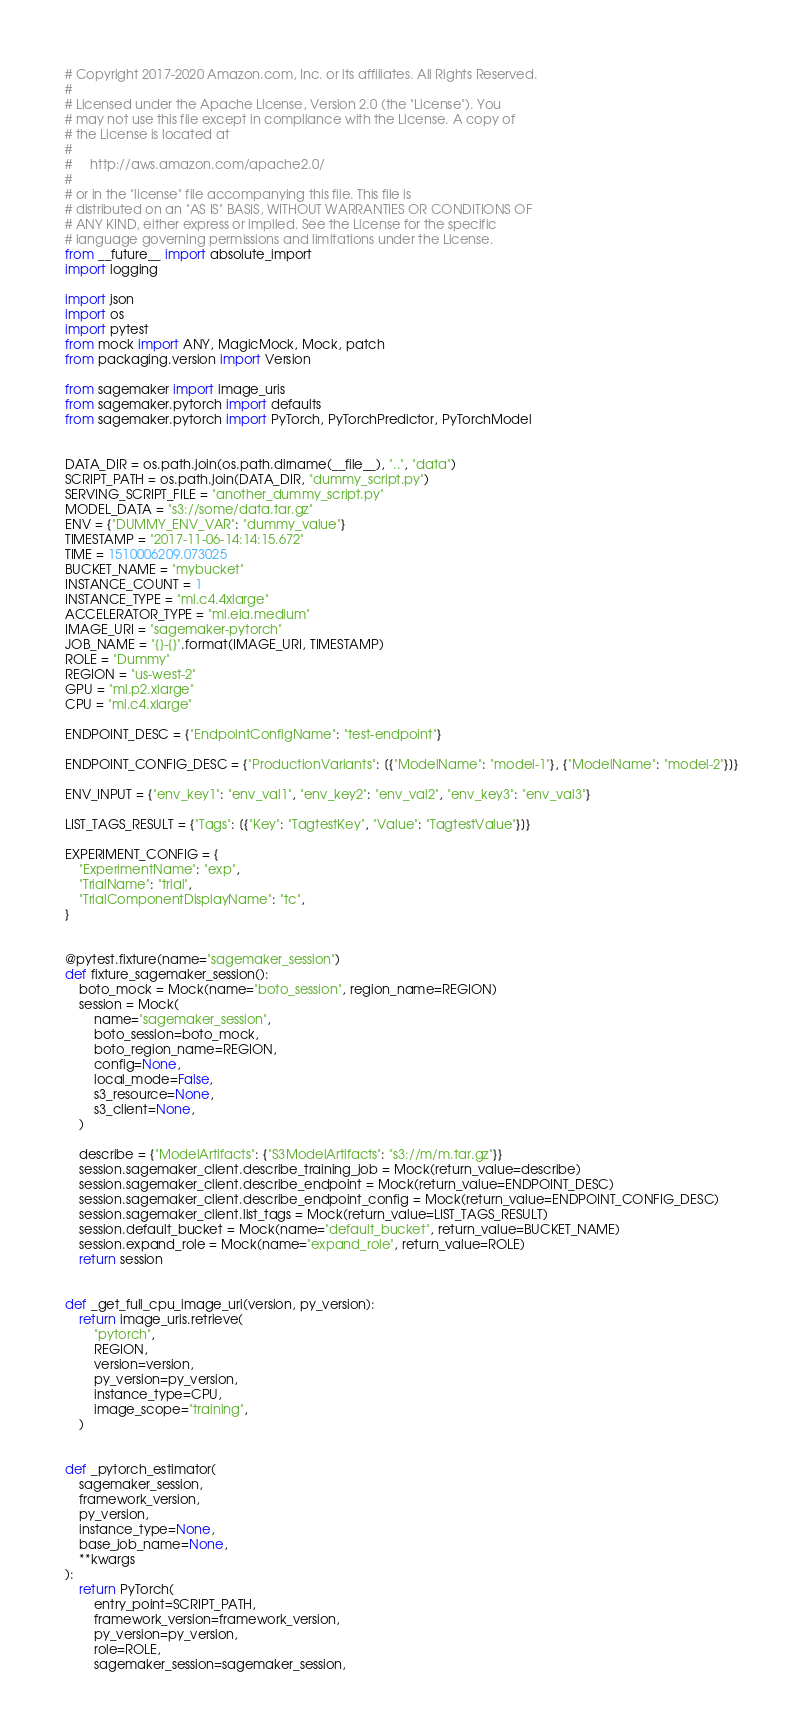Convert code to text. <code><loc_0><loc_0><loc_500><loc_500><_Python_># Copyright 2017-2020 Amazon.com, Inc. or its affiliates. All Rights Reserved.
#
# Licensed under the Apache License, Version 2.0 (the "License"). You
# may not use this file except in compliance with the License. A copy of
# the License is located at
#
#     http://aws.amazon.com/apache2.0/
#
# or in the "license" file accompanying this file. This file is
# distributed on an "AS IS" BASIS, WITHOUT WARRANTIES OR CONDITIONS OF
# ANY KIND, either express or implied. See the License for the specific
# language governing permissions and limitations under the License.
from __future__ import absolute_import
import logging

import json
import os
import pytest
from mock import ANY, MagicMock, Mock, patch
from packaging.version import Version

from sagemaker import image_uris
from sagemaker.pytorch import defaults
from sagemaker.pytorch import PyTorch, PyTorchPredictor, PyTorchModel


DATA_DIR = os.path.join(os.path.dirname(__file__), "..", "data")
SCRIPT_PATH = os.path.join(DATA_DIR, "dummy_script.py")
SERVING_SCRIPT_FILE = "another_dummy_script.py"
MODEL_DATA = "s3://some/data.tar.gz"
ENV = {"DUMMY_ENV_VAR": "dummy_value"}
TIMESTAMP = "2017-11-06-14:14:15.672"
TIME = 1510006209.073025
BUCKET_NAME = "mybucket"
INSTANCE_COUNT = 1
INSTANCE_TYPE = "ml.c4.4xlarge"
ACCELERATOR_TYPE = "ml.eia.medium"
IMAGE_URI = "sagemaker-pytorch"
JOB_NAME = "{}-{}".format(IMAGE_URI, TIMESTAMP)
ROLE = "Dummy"
REGION = "us-west-2"
GPU = "ml.p2.xlarge"
CPU = "ml.c4.xlarge"

ENDPOINT_DESC = {"EndpointConfigName": "test-endpoint"}

ENDPOINT_CONFIG_DESC = {"ProductionVariants": [{"ModelName": "model-1"}, {"ModelName": "model-2"}]}

ENV_INPUT = {"env_key1": "env_val1", "env_key2": "env_val2", "env_key3": "env_val3"}

LIST_TAGS_RESULT = {"Tags": [{"Key": "TagtestKey", "Value": "TagtestValue"}]}

EXPERIMENT_CONFIG = {
    "ExperimentName": "exp",
    "TrialName": "trial",
    "TrialComponentDisplayName": "tc",
}


@pytest.fixture(name="sagemaker_session")
def fixture_sagemaker_session():
    boto_mock = Mock(name="boto_session", region_name=REGION)
    session = Mock(
        name="sagemaker_session",
        boto_session=boto_mock,
        boto_region_name=REGION,
        config=None,
        local_mode=False,
        s3_resource=None,
        s3_client=None,
    )

    describe = {"ModelArtifacts": {"S3ModelArtifacts": "s3://m/m.tar.gz"}}
    session.sagemaker_client.describe_training_job = Mock(return_value=describe)
    session.sagemaker_client.describe_endpoint = Mock(return_value=ENDPOINT_DESC)
    session.sagemaker_client.describe_endpoint_config = Mock(return_value=ENDPOINT_CONFIG_DESC)
    session.sagemaker_client.list_tags = Mock(return_value=LIST_TAGS_RESULT)
    session.default_bucket = Mock(name="default_bucket", return_value=BUCKET_NAME)
    session.expand_role = Mock(name="expand_role", return_value=ROLE)
    return session


def _get_full_cpu_image_uri(version, py_version):
    return image_uris.retrieve(
        "pytorch",
        REGION,
        version=version,
        py_version=py_version,
        instance_type=CPU,
        image_scope="training",
    )


def _pytorch_estimator(
    sagemaker_session,
    framework_version,
    py_version,
    instance_type=None,
    base_job_name=None,
    **kwargs
):
    return PyTorch(
        entry_point=SCRIPT_PATH,
        framework_version=framework_version,
        py_version=py_version,
        role=ROLE,
        sagemaker_session=sagemaker_session,</code> 